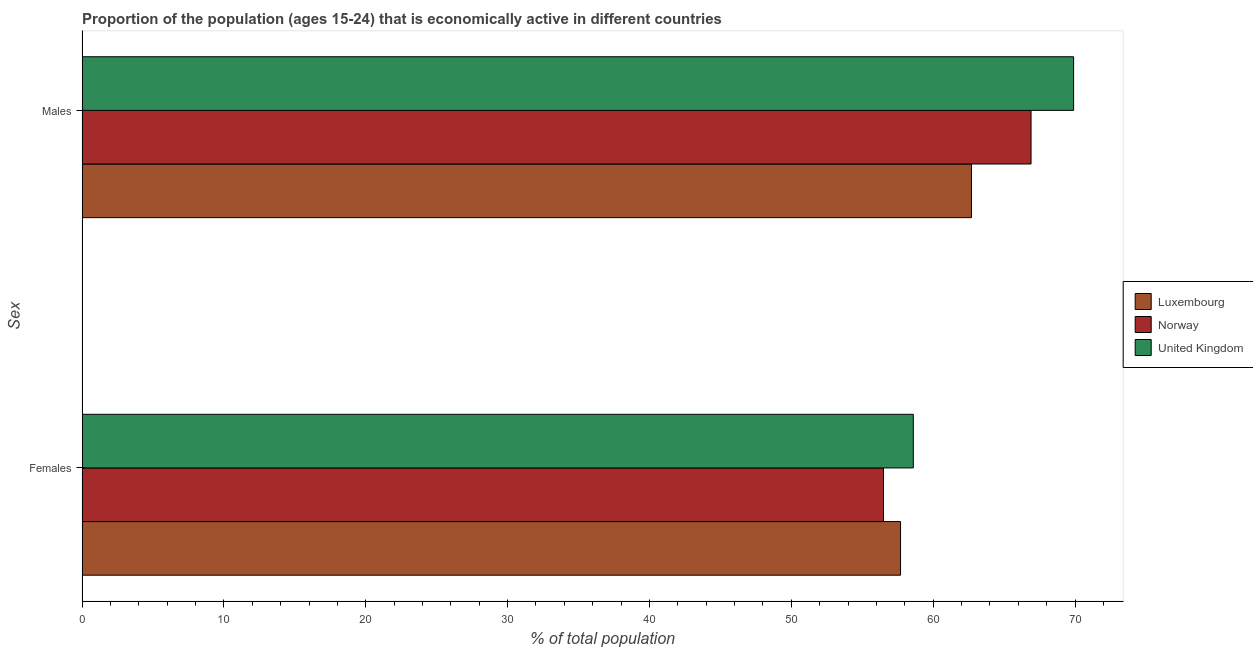How many groups of bars are there?
Ensure brevity in your answer.  2. Are the number of bars per tick equal to the number of legend labels?
Ensure brevity in your answer.  Yes. What is the label of the 2nd group of bars from the top?
Your answer should be compact. Females. What is the percentage of economically active male population in United Kingdom?
Your answer should be very brief. 69.9. Across all countries, what is the maximum percentage of economically active male population?
Keep it short and to the point. 69.9. Across all countries, what is the minimum percentage of economically active female population?
Make the answer very short. 56.5. What is the total percentage of economically active female population in the graph?
Provide a short and direct response. 172.8. What is the difference between the percentage of economically active male population in Luxembourg and that in Norway?
Provide a succinct answer. -4.2. What is the difference between the percentage of economically active male population in Luxembourg and the percentage of economically active female population in United Kingdom?
Offer a terse response. 4.1. What is the average percentage of economically active female population per country?
Give a very brief answer. 57.6. What is the difference between the percentage of economically active male population and percentage of economically active female population in Luxembourg?
Provide a short and direct response. 5. In how many countries, is the percentage of economically active female population greater than 18 %?
Give a very brief answer. 3. What is the ratio of the percentage of economically active female population in Luxembourg to that in United Kingdom?
Provide a succinct answer. 0.98. What does the 1st bar from the bottom in Females represents?
Give a very brief answer. Luxembourg. How many bars are there?
Your answer should be very brief. 6. Are all the bars in the graph horizontal?
Your response must be concise. Yes. What is the difference between two consecutive major ticks on the X-axis?
Make the answer very short. 10. Are the values on the major ticks of X-axis written in scientific E-notation?
Your answer should be compact. No. Where does the legend appear in the graph?
Ensure brevity in your answer.  Center right. How many legend labels are there?
Offer a terse response. 3. How are the legend labels stacked?
Offer a terse response. Vertical. What is the title of the graph?
Your answer should be compact. Proportion of the population (ages 15-24) that is economically active in different countries. Does "Ukraine" appear as one of the legend labels in the graph?
Provide a short and direct response. No. What is the label or title of the X-axis?
Make the answer very short. % of total population. What is the label or title of the Y-axis?
Your answer should be very brief. Sex. What is the % of total population in Luxembourg in Females?
Your answer should be compact. 57.7. What is the % of total population of Norway in Females?
Your answer should be compact. 56.5. What is the % of total population in United Kingdom in Females?
Provide a short and direct response. 58.6. What is the % of total population of Luxembourg in Males?
Provide a short and direct response. 62.7. What is the % of total population of Norway in Males?
Keep it short and to the point. 66.9. What is the % of total population of United Kingdom in Males?
Your response must be concise. 69.9. Across all Sex, what is the maximum % of total population in Luxembourg?
Provide a short and direct response. 62.7. Across all Sex, what is the maximum % of total population of Norway?
Ensure brevity in your answer.  66.9. Across all Sex, what is the maximum % of total population in United Kingdom?
Provide a short and direct response. 69.9. Across all Sex, what is the minimum % of total population of Luxembourg?
Your response must be concise. 57.7. Across all Sex, what is the minimum % of total population of Norway?
Provide a succinct answer. 56.5. Across all Sex, what is the minimum % of total population in United Kingdom?
Provide a short and direct response. 58.6. What is the total % of total population of Luxembourg in the graph?
Provide a succinct answer. 120.4. What is the total % of total population in Norway in the graph?
Ensure brevity in your answer.  123.4. What is the total % of total population of United Kingdom in the graph?
Ensure brevity in your answer.  128.5. What is the difference between the % of total population of Luxembourg in Females and that in Males?
Your answer should be very brief. -5. What is the difference between the % of total population of Luxembourg in Females and the % of total population of Norway in Males?
Your answer should be compact. -9.2. What is the average % of total population in Luxembourg per Sex?
Make the answer very short. 60.2. What is the average % of total population of Norway per Sex?
Provide a succinct answer. 61.7. What is the average % of total population in United Kingdom per Sex?
Provide a succinct answer. 64.25. What is the ratio of the % of total population in Luxembourg in Females to that in Males?
Provide a short and direct response. 0.92. What is the ratio of the % of total population of Norway in Females to that in Males?
Ensure brevity in your answer.  0.84. What is the ratio of the % of total population of United Kingdom in Females to that in Males?
Your answer should be compact. 0.84. What is the difference between the highest and the second highest % of total population in United Kingdom?
Offer a very short reply. 11.3. 